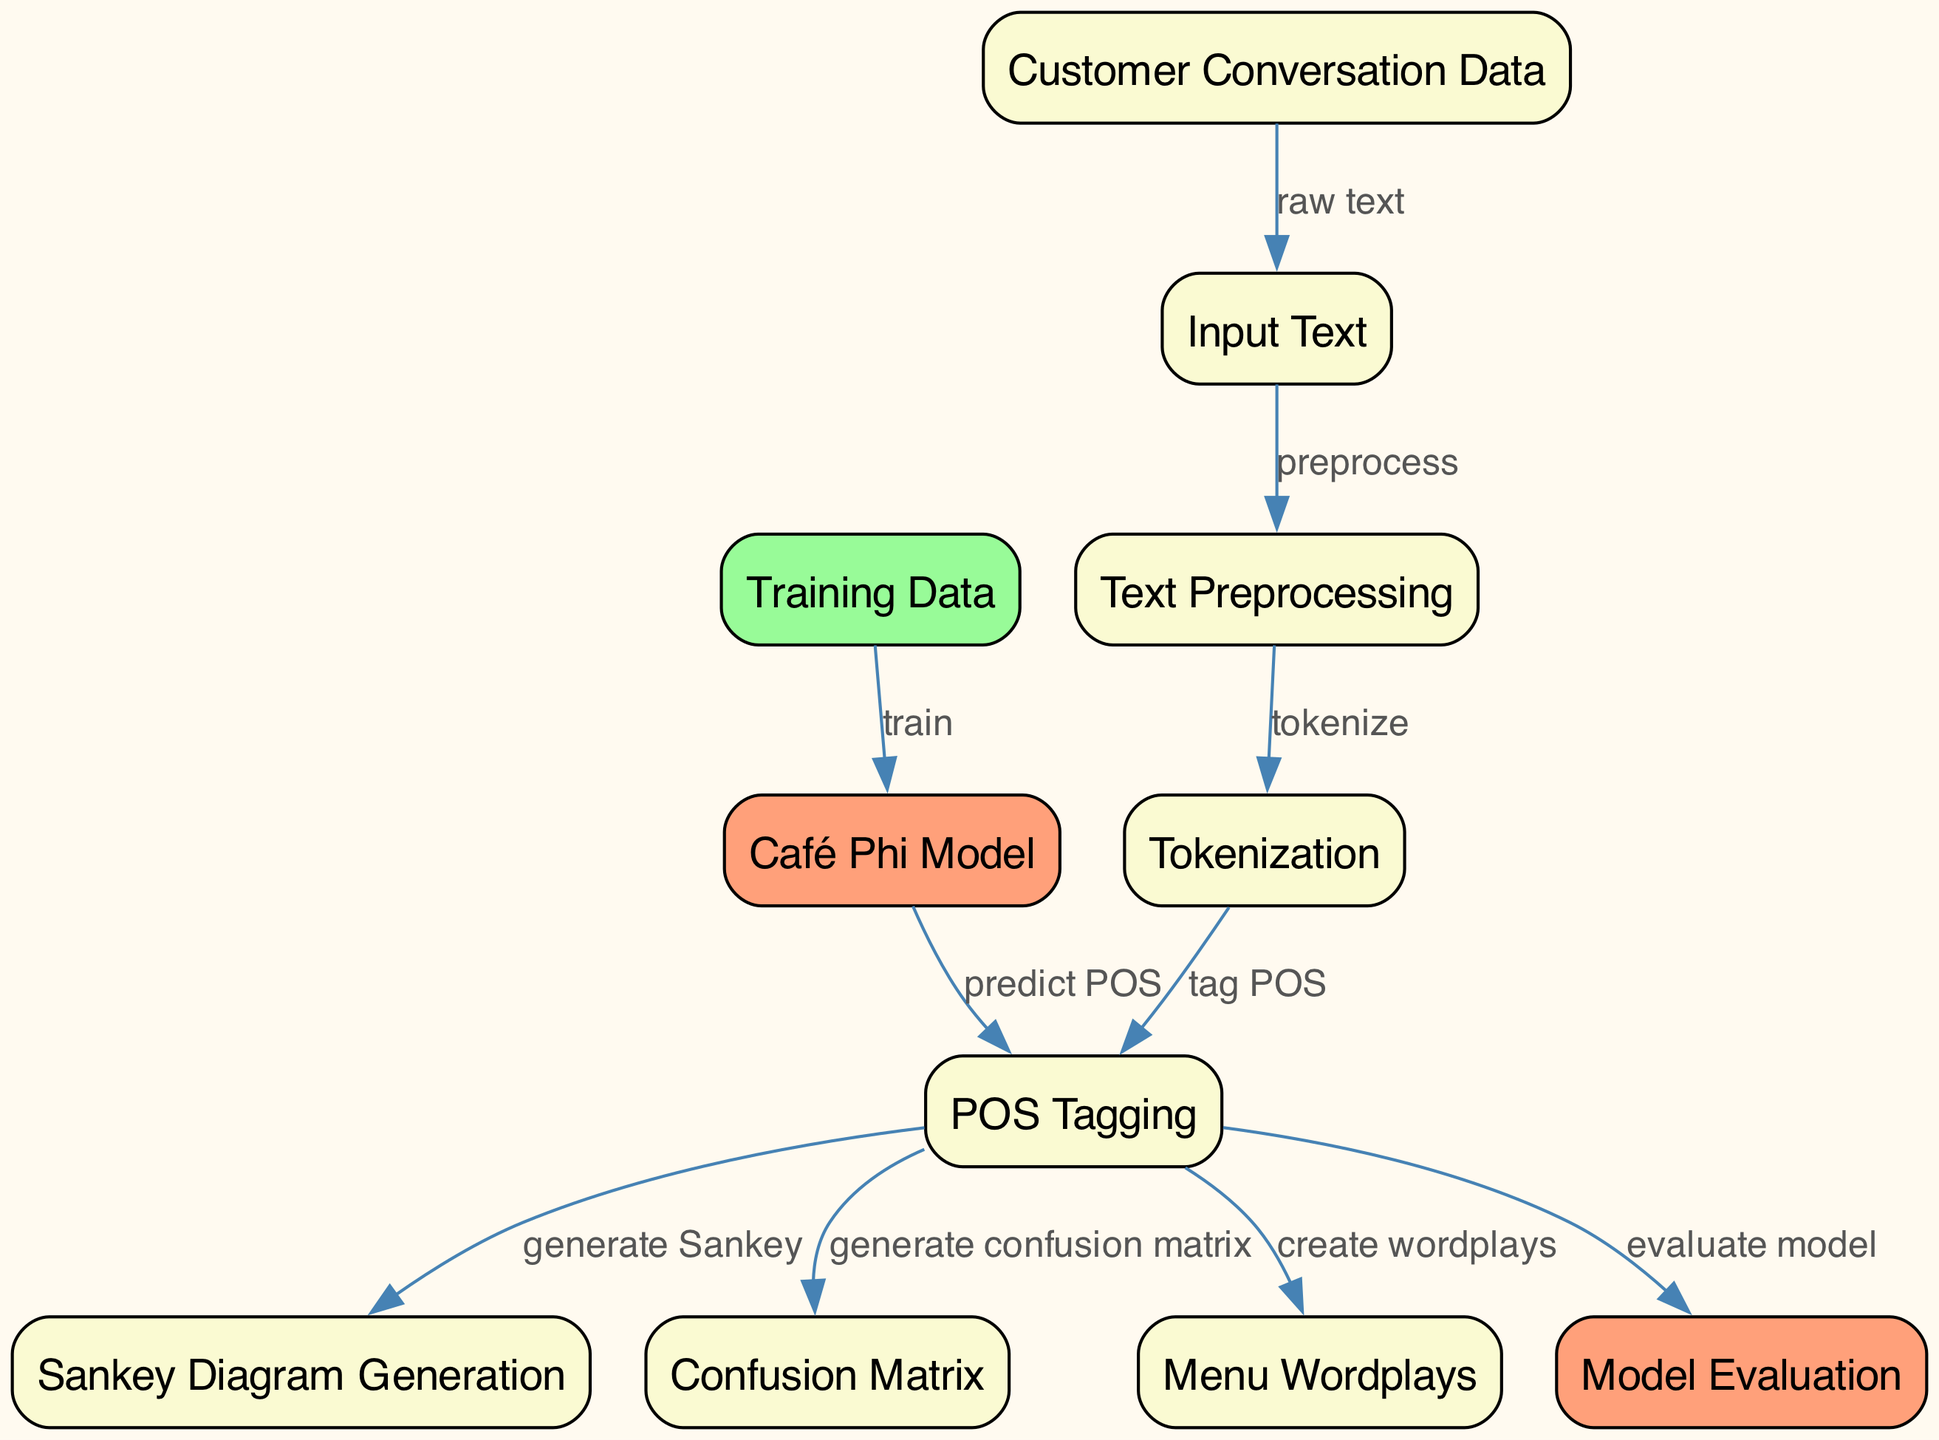What is the starting point of the data flow in the diagram? The starting point of the data flow is the "Customer Conversation Data" node, which provides the raw input text for processing.
Answer: Customer Conversation Data How many primary nodes are there in the diagram? By counting all unique nodes between the two classifications in the node list, we find that there are a total of 11 primary nodes.
Answer: 11 Which node generates the confusion matrix? The "POS Tagging" node is responsible for generating the confusion matrix as indicated by the directed edge labeled "generate confusion matrix" leading to this node.
Answer: POS Tagging What is the color used for model nodes in the diagram? Model nodes in the diagram are colored peach, indicated by the fill color value '#FFA07A' for nodes related to the model concept.
Answer: Peach Which node directly follows "POS Tagging" in the flow? The "Sankey Diagram Generation" follows the "POS Tagging" node according to the directed edge labeled "generate Sankey" leading from "POS Tagging" to this node.
Answer: Sankey Diagram Generation How is the "Café Phi Model" node classified in the diagram? The "Café Phi Model" node is classified as a model node since it involves the training process related to the Café application.
Answer: Model What flow occurs right before the model evaluation? The flow leading to model evaluation involves processing through "POS Tagging," which feeds its output into the "Model Evaluation" node, signifying the evaluation process.
Answer: POS Tagging Which node takes input from "Training Data"? The "Café Phi Model" node takes input from the "Training Data," as shown by the directed edge labeled "train."
Answer: Café Phi Model What is the relationship between "Tokenization" and "Text Preprocessing"? "Tokenization" is the subsequent step that follows "Text Preprocessing," which is indicated by the directed edge labeled "tokenize."
Answer: Tokenization 